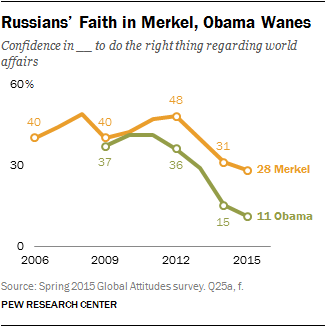Specify some key components in this picture. The green line of data represents President Obama's actions. In 2009, the data point for President Obama was 0.37. 